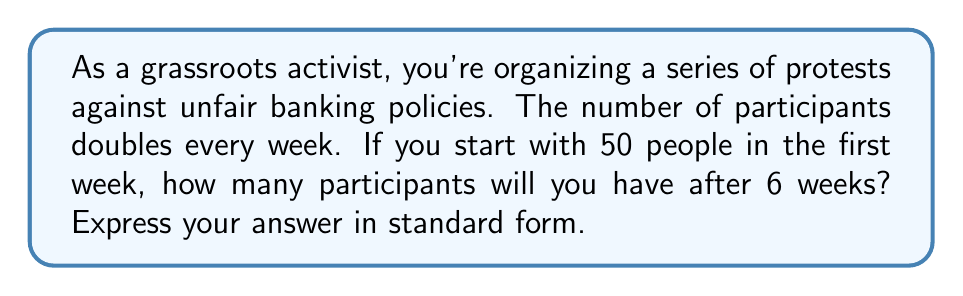Provide a solution to this math problem. Let's approach this step-by-step:

1) We start with 50 people in the first week.
2) The number doubles every week, which means we're dealing with exponential growth.
3) The growth can be represented by the formula: $P = 50 \cdot 2^n$, where $P$ is the number of participants and $n$ is the number of weeks.
4) We want to know the number of participants after 6 weeks, so we substitute $n = 6$:

   $P = 50 \cdot 2^6$

5) Let's calculate $2^6$:
   $2^6 = 2 \cdot 2 \cdot 2 \cdot 2 \cdot 2 \cdot 2 = 64$

6) Now we can complete our calculation:
   $P = 50 \cdot 64 = 3200$

Therefore, after 6 weeks, there will be 3200 participants in the protest.
Answer: 3200 